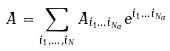<formula> <loc_0><loc_0><loc_500><loc_500>A = \sum _ { i _ { 1 } , \dots , i _ { N } } A _ { i _ { 1 } \dots i _ { N _ { a } } } { e } ^ { i _ { 1 } \dots i _ { N _ { a } } }</formula> 